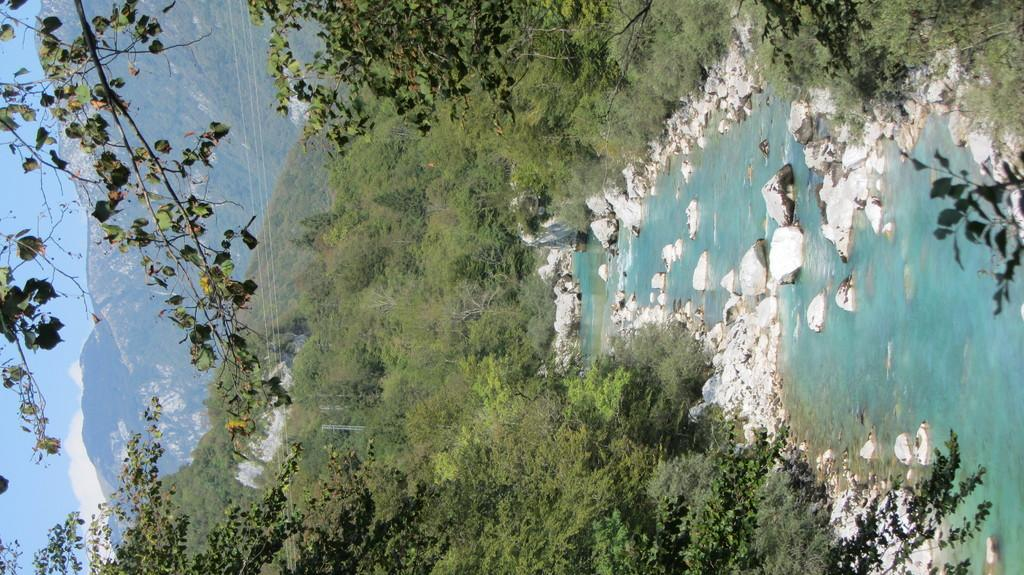What is the primary element present in the image? There is water in the image. What other natural features can be seen in the image? There are rocks, trees, and hills visible in the image. What is visible in the background of the image? The sky is visible in the background of the image. What type of drug can be seen growing in the image? There is no drug present in the image; it features natural elements such as water, rocks, trees, and hills. How many clovers are visible in the image? There is no clover present in the image. 